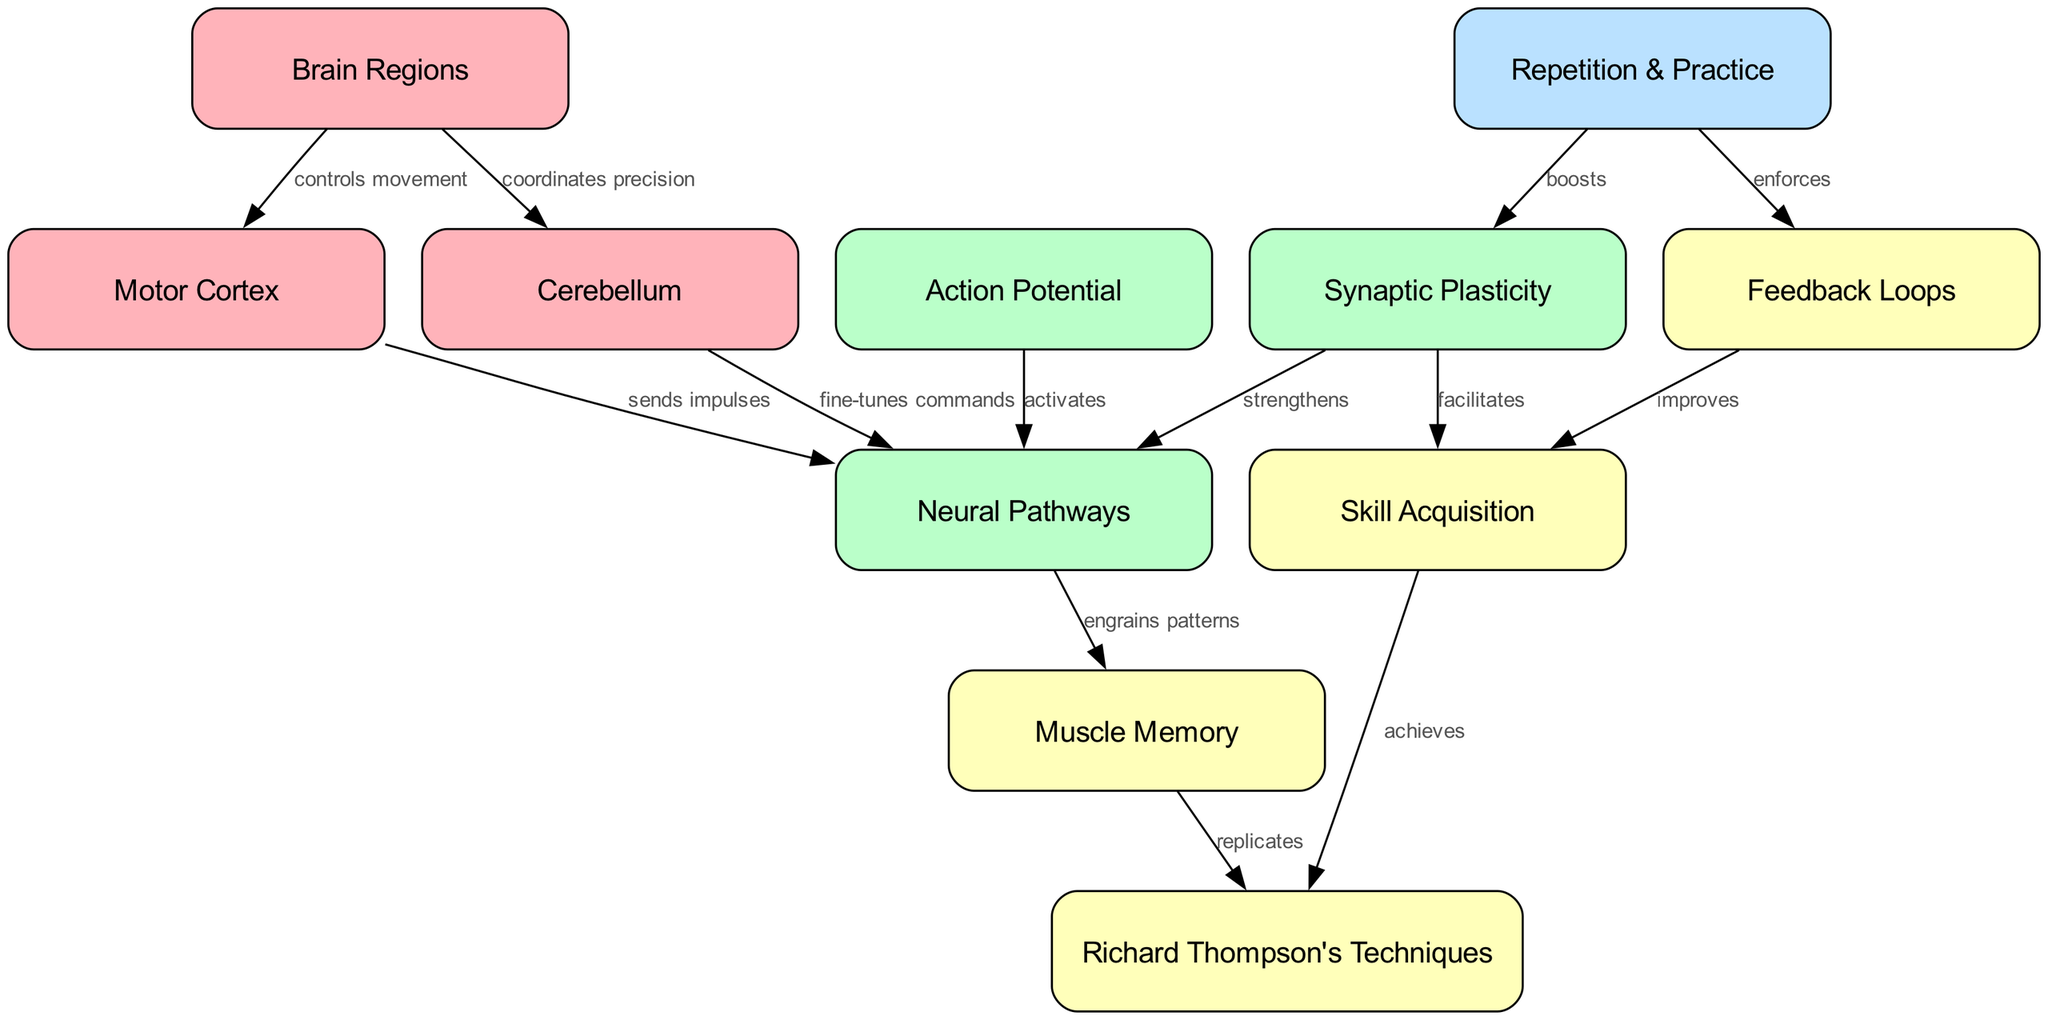What is the main function of the motor cortex in relation to guitar playing? The motor cortex controls movement, which is essential for playing guitar techniques neatly. Therefore, it plays a critical role in initiating the precise finger movements needed for complex guitar techniques.
Answer: controls movement How does muscle memory relate to Richard Thompson's techniques? Muscle memory is the process through which repetitive movements are engrained, allowing one to replicate specific techniques. In this case, it directly relates to how muscle memory allows the guitarist to perform Richard Thompson's techniques.
Answer: replicates How many nodes are present in the diagram? The diagram displays a total of 11 nodes, which include various brain regions, processes, and skills relevant to neuroplasticity and guitar learning.
Answer: 11 Which two brain regions are directly connected to the concept of neural pathways? The motor cortex and cerebellum are both connected to neural pathways, as they send impulses and fine-tune commands, respectively, influencing the neural connectivity essential for motor learning.
Answer: motor cortex, cerebellum What contributes to skill acquisition according to the diagram? Skill acquisition is facilitated by synaptic plasticity, which strengthens the neural pathways through practice, and is also improved by feedback loops that reinforce learning from previous attempts.
Answer: synaptic plasticity, feedback loops What role does repetition and practice play in the diagram? Repetition and practice boost synaptic plasticity, which is crucial for enhancing the strength of neural pathways, and it also enforces feedback loops that improve skill acquisition over time.
Answer: boosts, enforces How many edges are present in the diagram? The diagram contains a total of 12 edges that depict the relationships and flows between various concepts, from brain regions to skill acquisition processes.
Answer: 12 What activates the neural pathways according to the diagram? The action potential activates the neural pathways, which is necessary for sending impulses that are vital for muscle memory and skilled movements like guitar playing.
Answer: action potential What is the relationship between synaptic plasticity and skill acquisition? Synaptic plasticity facilitates skill acquisition by strengthening the neural connections that are developed through practice, allowing for more effective learning and execution of complex techniques.
Answer: facilitates 